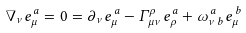Convert formula to latex. <formula><loc_0><loc_0><loc_500><loc_500>\nabla _ { \nu } e _ { \mu } ^ { \, a } = 0 = \partial _ { \nu } e _ { \mu } ^ { \, a } - \Gamma ^ { \rho } _ { \, \mu \nu } e _ { \rho } ^ { \, a } + \omega _ { \nu \, b } ^ { \, a } e _ { \mu } ^ { \, b }</formula> 